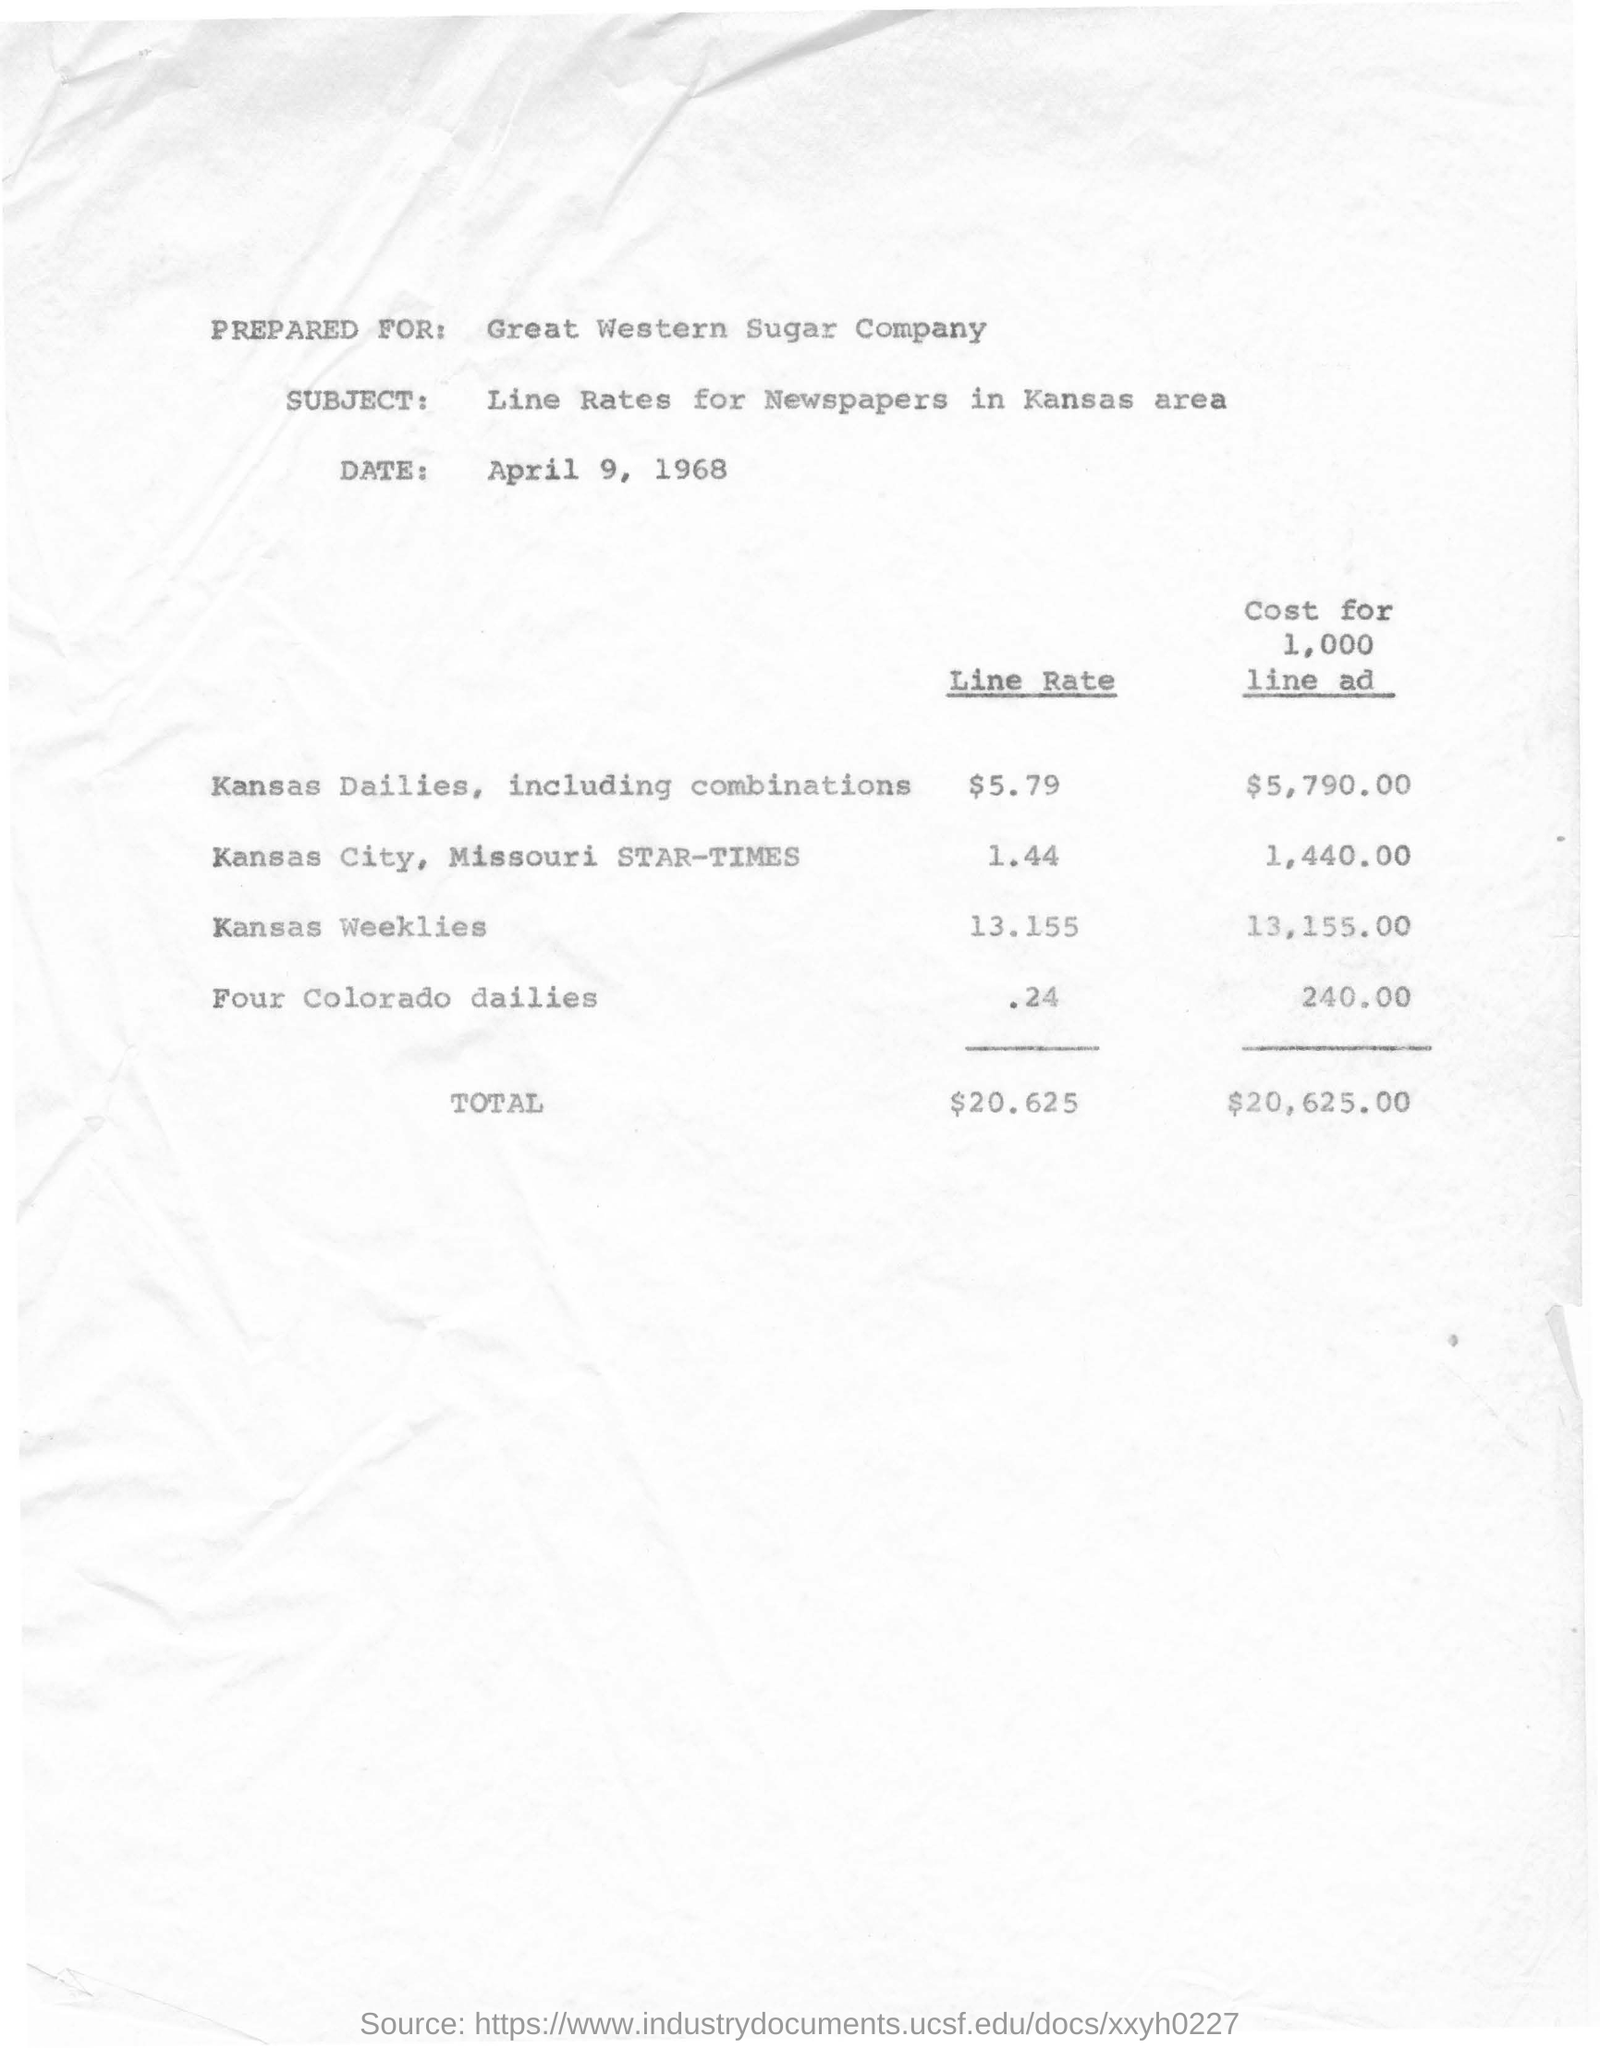Draw attention to some important aspects in this diagram. The cost for a 1000-line advertisement in the Kansas City, Missouri Star Times is $1,440.00. The total cost for a 1000 line ad is $20,625.00. The line rate for four Colorado dailies is approximately 0.24. The total amount for line rate is $20.625. The cost for a thousand line ad in Kansas weeklies is $13,155.00. 